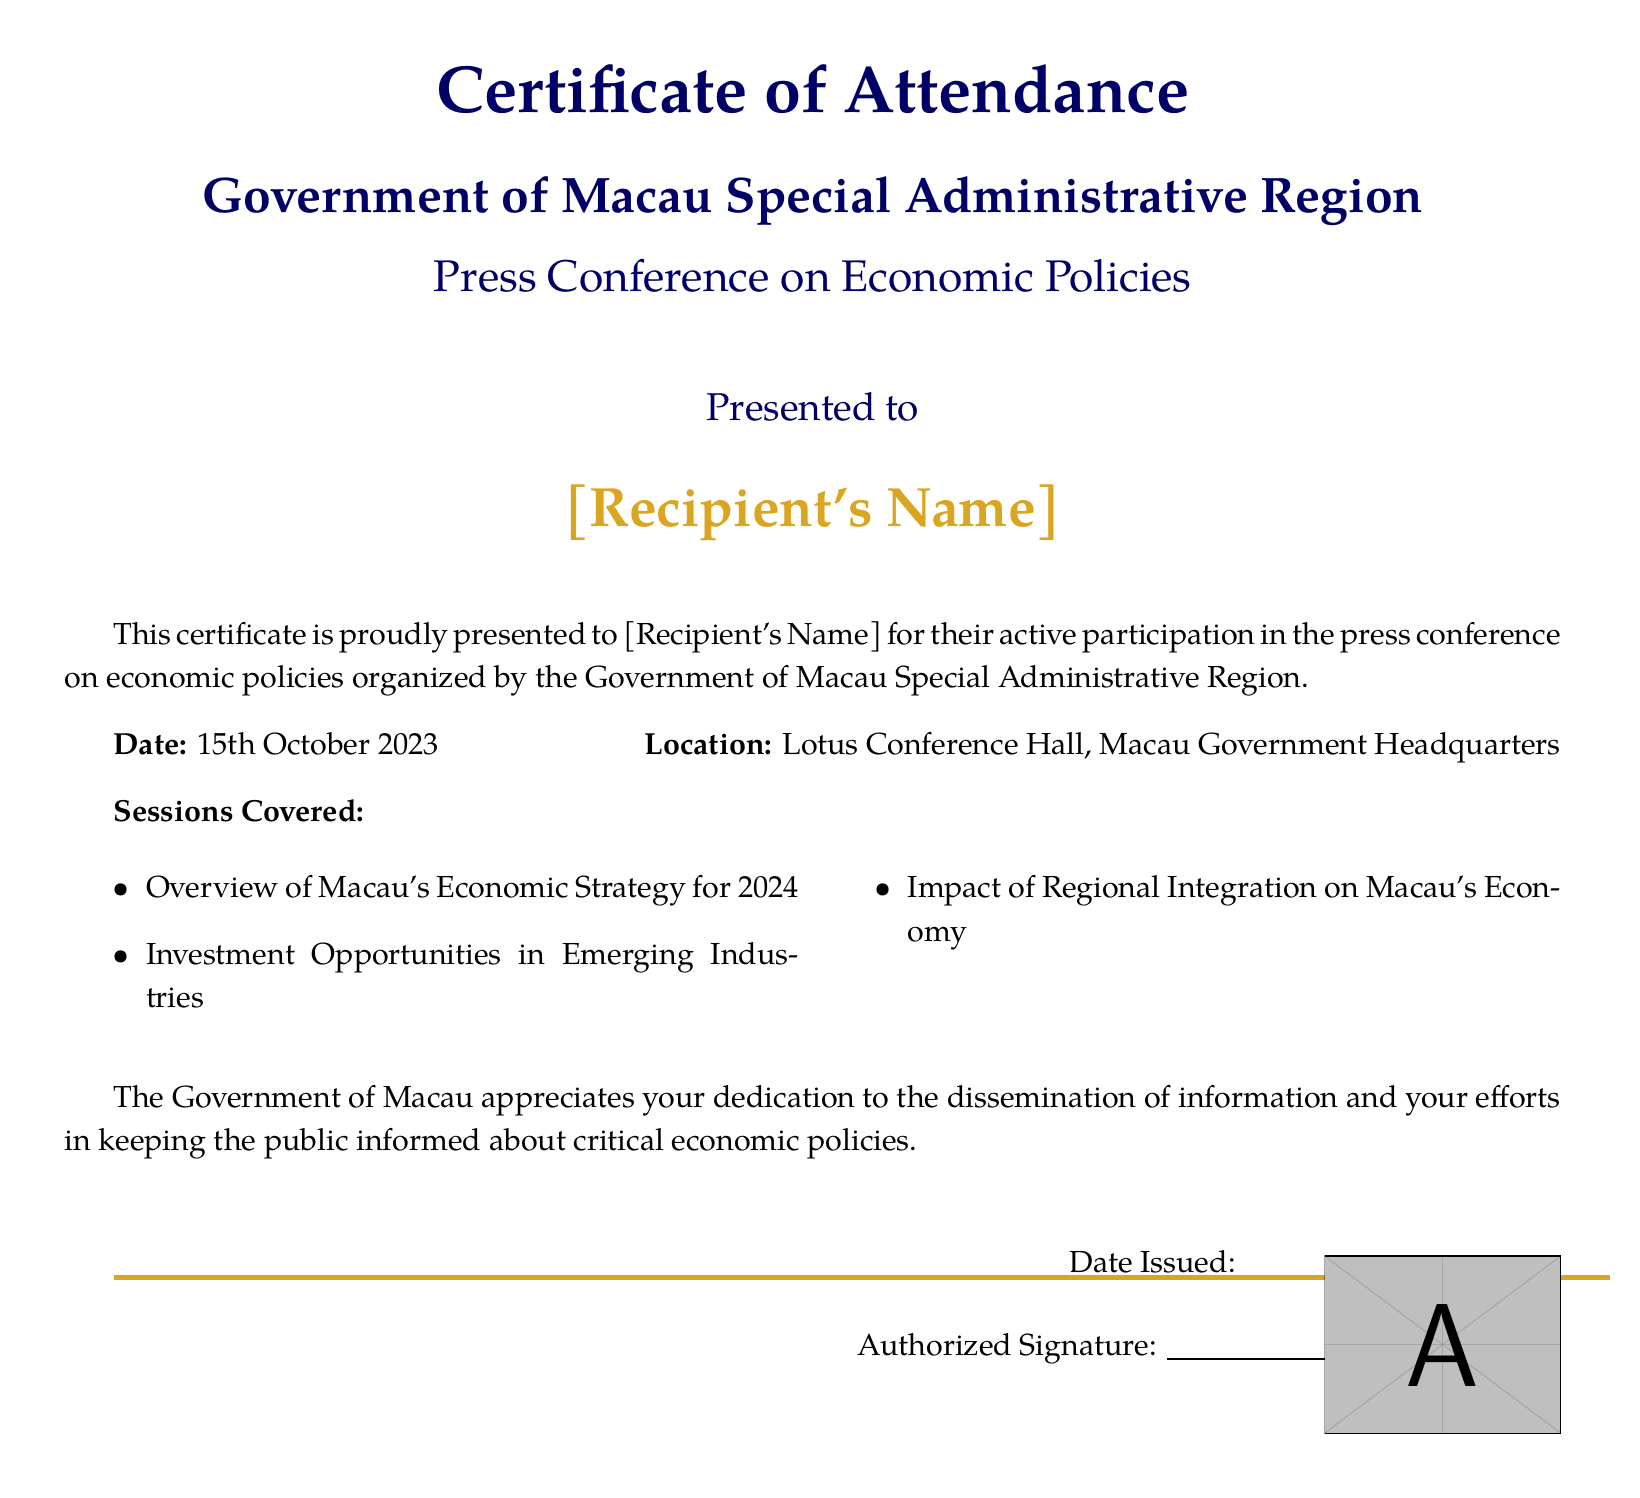What is the title of the certificate? The title of the certificate clearly states "Certificate of Attendance".
Answer: Certificate of Attendance Who is the issuing authority? The issuing authority is identified as "Government of Macau Special Administrative Region".
Answer: Government of Macau Special Administrative Region What is the date of the press conference? The document specifies the date as "15th October 2023".
Answer: 15th October 2023 Where was the press conference held? The location mentioned in the document is "Lotus Conference Hall, Macau Government Headquarters".
Answer: Lotus Conference Hall, Macau Government Headquarters What is one of the sessions covered? The document lists multiple sessions, one of which is "Overview of Macau's Economic Strategy for 2024".
Answer: Overview of Macau's Economic Strategy for 2024 What color is used for the recipient's name? The color specified for the recipient's name is "goldaccent".
Answer: goldaccent What is noted as appreciated by the government? The government states appreciation for "dedication to the dissemination of information".
Answer: dedication to the dissemination of information What is required where it says "Date Issued"? The document has a blank line under "Date Issued" which indicates that a date should be filled in.
Answer: Date should be filled in Who should sign the certificate? The document specifies that there should be an "Authorized Signature".
Answer: Authorized Signature 